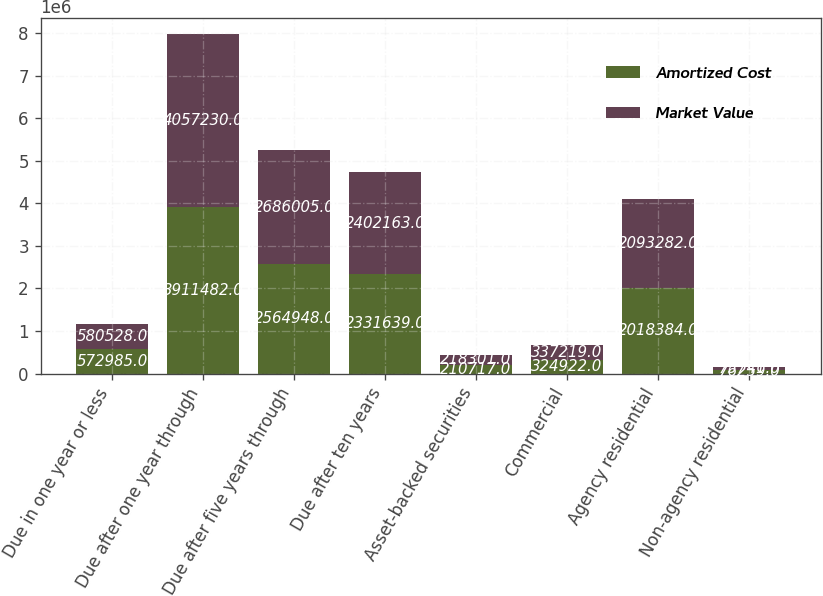Convert chart to OTSL. <chart><loc_0><loc_0><loc_500><loc_500><stacked_bar_chart><ecel><fcel>Due in one year or less<fcel>Due after one year through<fcel>Due after five years through<fcel>Due after ten years<fcel>Asset-backed securities<fcel>Commercial<fcel>Agency residential<fcel>Non-agency residential<nl><fcel>Amortized Cost<fcel>572985<fcel>3.91148e+06<fcel>2.56495e+06<fcel>2.33164e+06<fcel>210717<fcel>324922<fcel>2.01838e+06<fcel>76259<nl><fcel>Market Value<fcel>580528<fcel>4.05723e+06<fcel>2.686e+06<fcel>2.40216e+06<fcel>218301<fcel>337219<fcel>2.09328e+06<fcel>75741<nl></chart> 